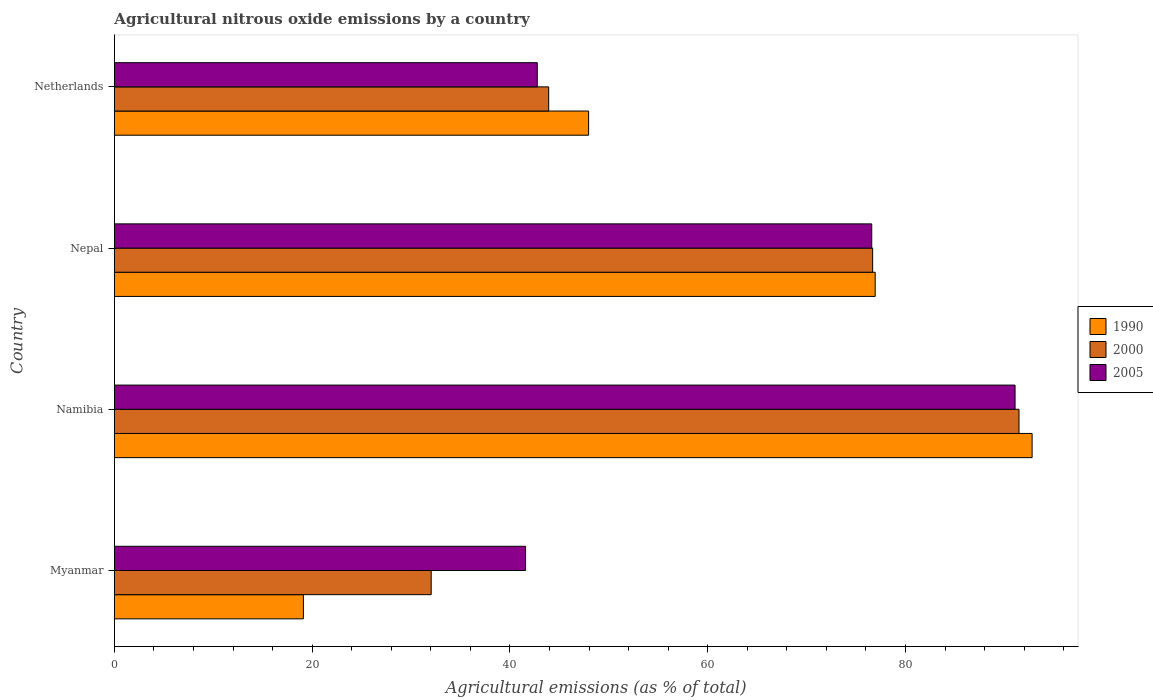How many different coloured bars are there?
Offer a terse response. 3. How many groups of bars are there?
Ensure brevity in your answer.  4. Are the number of bars per tick equal to the number of legend labels?
Give a very brief answer. Yes. What is the label of the 2nd group of bars from the top?
Give a very brief answer. Nepal. What is the amount of agricultural nitrous oxide emitted in 2000 in Myanmar?
Your answer should be compact. 32.03. Across all countries, what is the maximum amount of agricultural nitrous oxide emitted in 2000?
Provide a succinct answer. 91.48. Across all countries, what is the minimum amount of agricultural nitrous oxide emitted in 2005?
Keep it short and to the point. 41.58. In which country was the amount of agricultural nitrous oxide emitted in 2005 maximum?
Provide a short and direct response. Namibia. In which country was the amount of agricultural nitrous oxide emitted in 2000 minimum?
Offer a very short reply. Myanmar. What is the total amount of agricultural nitrous oxide emitted in 2000 in the graph?
Offer a terse response. 244.11. What is the difference between the amount of agricultural nitrous oxide emitted in 2005 in Nepal and that in Netherlands?
Make the answer very short. 33.82. What is the difference between the amount of agricultural nitrous oxide emitted in 2005 in Myanmar and the amount of agricultural nitrous oxide emitted in 2000 in Namibia?
Keep it short and to the point. -49.9. What is the average amount of agricultural nitrous oxide emitted in 2000 per country?
Your response must be concise. 61.03. What is the difference between the amount of agricultural nitrous oxide emitted in 1990 and amount of agricultural nitrous oxide emitted in 2005 in Namibia?
Give a very brief answer. 1.72. What is the ratio of the amount of agricultural nitrous oxide emitted in 1990 in Namibia to that in Nepal?
Give a very brief answer. 1.21. What is the difference between the highest and the second highest amount of agricultural nitrous oxide emitted in 2000?
Give a very brief answer. 14.8. What is the difference between the highest and the lowest amount of agricultural nitrous oxide emitted in 2005?
Your answer should be compact. 49.5. Is the sum of the amount of agricultural nitrous oxide emitted in 2000 in Namibia and Nepal greater than the maximum amount of agricultural nitrous oxide emitted in 2005 across all countries?
Your answer should be compact. Yes. What does the 1st bar from the top in Namibia represents?
Your answer should be compact. 2005. What does the 2nd bar from the bottom in Myanmar represents?
Give a very brief answer. 2000. Are all the bars in the graph horizontal?
Ensure brevity in your answer.  Yes. How many countries are there in the graph?
Provide a short and direct response. 4. Does the graph contain any zero values?
Offer a terse response. No. How many legend labels are there?
Ensure brevity in your answer.  3. How are the legend labels stacked?
Provide a short and direct response. Vertical. What is the title of the graph?
Offer a very short reply. Agricultural nitrous oxide emissions by a country. What is the label or title of the X-axis?
Offer a very short reply. Agricultural emissions (as % of total). What is the Agricultural emissions (as % of total) of 1990 in Myanmar?
Your answer should be compact. 19.11. What is the Agricultural emissions (as % of total) in 2000 in Myanmar?
Offer a very short reply. 32.03. What is the Agricultural emissions (as % of total) in 2005 in Myanmar?
Keep it short and to the point. 41.58. What is the Agricultural emissions (as % of total) of 1990 in Namibia?
Make the answer very short. 92.8. What is the Agricultural emissions (as % of total) in 2000 in Namibia?
Keep it short and to the point. 91.48. What is the Agricultural emissions (as % of total) of 2005 in Namibia?
Offer a very short reply. 91.08. What is the Agricultural emissions (as % of total) of 1990 in Nepal?
Make the answer very short. 76.93. What is the Agricultural emissions (as % of total) in 2000 in Nepal?
Provide a succinct answer. 76.68. What is the Agricultural emissions (as % of total) of 2005 in Nepal?
Provide a short and direct response. 76.59. What is the Agricultural emissions (as % of total) of 1990 in Netherlands?
Make the answer very short. 47.95. What is the Agricultural emissions (as % of total) of 2000 in Netherlands?
Your answer should be compact. 43.92. What is the Agricultural emissions (as % of total) of 2005 in Netherlands?
Give a very brief answer. 42.76. Across all countries, what is the maximum Agricultural emissions (as % of total) in 1990?
Make the answer very short. 92.8. Across all countries, what is the maximum Agricultural emissions (as % of total) of 2000?
Ensure brevity in your answer.  91.48. Across all countries, what is the maximum Agricultural emissions (as % of total) in 2005?
Give a very brief answer. 91.08. Across all countries, what is the minimum Agricultural emissions (as % of total) of 1990?
Ensure brevity in your answer.  19.11. Across all countries, what is the minimum Agricultural emissions (as % of total) of 2000?
Offer a terse response. 32.03. Across all countries, what is the minimum Agricultural emissions (as % of total) of 2005?
Your answer should be very brief. 41.58. What is the total Agricultural emissions (as % of total) in 1990 in the graph?
Provide a short and direct response. 236.8. What is the total Agricultural emissions (as % of total) of 2000 in the graph?
Offer a terse response. 244.11. What is the total Agricultural emissions (as % of total) in 2005 in the graph?
Provide a succinct answer. 252.01. What is the difference between the Agricultural emissions (as % of total) in 1990 in Myanmar and that in Namibia?
Your answer should be compact. -73.69. What is the difference between the Agricultural emissions (as % of total) of 2000 in Myanmar and that in Namibia?
Give a very brief answer. -59.45. What is the difference between the Agricultural emissions (as % of total) in 2005 in Myanmar and that in Namibia?
Make the answer very short. -49.5. What is the difference between the Agricultural emissions (as % of total) in 1990 in Myanmar and that in Nepal?
Make the answer very short. -57.82. What is the difference between the Agricultural emissions (as % of total) of 2000 in Myanmar and that in Nepal?
Keep it short and to the point. -44.65. What is the difference between the Agricultural emissions (as % of total) of 2005 in Myanmar and that in Nepal?
Ensure brevity in your answer.  -35.01. What is the difference between the Agricultural emissions (as % of total) in 1990 in Myanmar and that in Netherlands?
Give a very brief answer. -28.84. What is the difference between the Agricultural emissions (as % of total) in 2000 in Myanmar and that in Netherlands?
Your response must be concise. -11.88. What is the difference between the Agricultural emissions (as % of total) in 2005 in Myanmar and that in Netherlands?
Offer a very short reply. -1.19. What is the difference between the Agricultural emissions (as % of total) of 1990 in Namibia and that in Nepal?
Your answer should be very brief. 15.87. What is the difference between the Agricultural emissions (as % of total) of 2000 in Namibia and that in Nepal?
Your answer should be very brief. 14.8. What is the difference between the Agricultural emissions (as % of total) in 2005 in Namibia and that in Nepal?
Your answer should be very brief. 14.49. What is the difference between the Agricultural emissions (as % of total) in 1990 in Namibia and that in Netherlands?
Provide a succinct answer. 44.85. What is the difference between the Agricultural emissions (as % of total) of 2000 in Namibia and that in Netherlands?
Your answer should be compact. 47.56. What is the difference between the Agricultural emissions (as % of total) of 2005 in Namibia and that in Netherlands?
Give a very brief answer. 48.32. What is the difference between the Agricultural emissions (as % of total) of 1990 in Nepal and that in Netherlands?
Give a very brief answer. 28.98. What is the difference between the Agricultural emissions (as % of total) of 2000 in Nepal and that in Netherlands?
Ensure brevity in your answer.  32.76. What is the difference between the Agricultural emissions (as % of total) in 2005 in Nepal and that in Netherlands?
Your answer should be very brief. 33.82. What is the difference between the Agricultural emissions (as % of total) of 1990 in Myanmar and the Agricultural emissions (as % of total) of 2000 in Namibia?
Your answer should be compact. -72.37. What is the difference between the Agricultural emissions (as % of total) of 1990 in Myanmar and the Agricultural emissions (as % of total) of 2005 in Namibia?
Offer a terse response. -71.97. What is the difference between the Agricultural emissions (as % of total) of 2000 in Myanmar and the Agricultural emissions (as % of total) of 2005 in Namibia?
Your answer should be compact. -59.05. What is the difference between the Agricultural emissions (as % of total) in 1990 in Myanmar and the Agricultural emissions (as % of total) in 2000 in Nepal?
Ensure brevity in your answer.  -57.57. What is the difference between the Agricultural emissions (as % of total) of 1990 in Myanmar and the Agricultural emissions (as % of total) of 2005 in Nepal?
Give a very brief answer. -57.48. What is the difference between the Agricultural emissions (as % of total) of 2000 in Myanmar and the Agricultural emissions (as % of total) of 2005 in Nepal?
Ensure brevity in your answer.  -44.55. What is the difference between the Agricultural emissions (as % of total) of 1990 in Myanmar and the Agricultural emissions (as % of total) of 2000 in Netherlands?
Your response must be concise. -24.81. What is the difference between the Agricultural emissions (as % of total) of 1990 in Myanmar and the Agricultural emissions (as % of total) of 2005 in Netherlands?
Your answer should be compact. -23.65. What is the difference between the Agricultural emissions (as % of total) in 2000 in Myanmar and the Agricultural emissions (as % of total) in 2005 in Netherlands?
Your response must be concise. -10.73. What is the difference between the Agricultural emissions (as % of total) in 1990 in Namibia and the Agricultural emissions (as % of total) in 2000 in Nepal?
Offer a very short reply. 16.13. What is the difference between the Agricultural emissions (as % of total) in 1990 in Namibia and the Agricultural emissions (as % of total) in 2005 in Nepal?
Provide a succinct answer. 16.22. What is the difference between the Agricultural emissions (as % of total) of 2000 in Namibia and the Agricultural emissions (as % of total) of 2005 in Nepal?
Your answer should be very brief. 14.89. What is the difference between the Agricultural emissions (as % of total) of 1990 in Namibia and the Agricultural emissions (as % of total) of 2000 in Netherlands?
Offer a very short reply. 48.89. What is the difference between the Agricultural emissions (as % of total) in 1990 in Namibia and the Agricultural emissions (as % of total) in 2005 in Netherlands?
Give a very brief answer. 50.04. What is the difference between the Agricultural emissions (as % of total) in 2000 in Namibia and the Agricultural emissions (as % of total) in 2005 in Netherlands?
Provide a short and direct response. 48.72. What is the difference between the Agricultural emissions (as % of total) in 1990 in Nepal and the Agricultural emissions (as % of total) in 2000 in Netherlands?
Provide a short and direct response. 33.02. What is the difference between the Agricultural emissions (as % of total) of 1990 in Nepal and the Agricultural emissions (as % of total) of 2005 in Netherlands?
Make the answer very short. 34.17. What is the difference between the Agricultural emissions (as % of total) of 2000 in Nepal and the Agricultural emissions (as % of total) of 2005 in Netherlands?
Provide a short and direct response. 33.92. What is the average Agricultural emissions (as % of total) of 1990 per country?
Provide a succinct answer. 59.2. What is the average Agricultural emissions (as % of total) in 2000 per country?
Your response must be concise. 61.03. What is the average Agricultural emissions (as % of total) of 2005 per country?
Your answer should be compact. 63. What is the difference between the Agricultural emissions (as % of total) of 1990 and Agricultural emissions (as % of total) of 2000 in Myanmar?
Provide a short and direct response. -12.92. What is the difference between the Agricultural emissions (as % of total) in 1990 and Agricultural emissions (as % of total) in 2005 in Myanmar?
Offer a terse response. -22.47. What is the difference between the Agricultural emissions (as % of total) of 2000 and Agricultural emissions (as % of total) of 2005 in Myanmar?
Keep it short and to the point. -9.54. What is the difference between the Agricultural emissions (as % of total) in 1990 and Agricultural emissions (as % of total) in 2000 in Namibia?
Your answer should be compact. 1.32. What is the difference between the Agricultural emissions (as % of total) in 1990 and Agricultural emissions (as % of total) in 2005 in Namibia?
Your answer should be very brief. 1.72. What is the difference between the Agricultural emissions (as % of total) of 2000 and Agricultural emissions (as % of total) of 2005 in Namibia?
Provide a short and direct response. 0.4. What is the difference between the Agricultural emissions (as % of total) of 1990 and Agricultural emissions (as % of total) of 2000 in Nepal?
Your answer should be compact. 0.26. What is the difference between the Agricultural emissions (as % of total) of 1990 and Agricultural emissions (as % of total) of 2005 in Nepal?
Your answer should be very brief. 0.35. What is the difference between the Agricultural emissions (as % of total) in 2000 and Agricultural emissions (as % of total) in 2005 in Nepal?
Offer a very short reply. 0.09. What is the difference between the Agricultural emissions (as % of total) in 1990 and Agricultural emissions (as % of total) in 2000 in Netherlands?
Your answer should be compact. 4.04. What is the difference between the Agricultural emissions (as % of total) of 1990 and Agricultural emissions (as % of total) of 2005 in Netherlands?
Ensure brevity in your answer.  5.19. What is the difference between the Agricultural emissions (as % of total) of 2000 and Agricultural emissions (as % of total) of 2005 in Netherlands?
Your answer should be compact. 1.15. What is the ratio of the Agricultural emissions (as % of total) in 1990 in Myanmar to that in Namibia?
Offer a very short reply. 0.21. What is the ratio of the Agricultural emissions (as % of total) of 2000 in Myanmar to that in Namibia?
Provide a succinct answer. 0.35. What is the ratio of the Agricultural emissions (as % of total) in 2005 in Myanmar to that in Namibia?
Give a very brief answer. 0.46. What is the ratio of the Agricultural emissions (as % of total) of 1990 in Myanmar to that in Nepal?
Offer a terse response. 0.25. What is the ratio of the Agricultural emissions (as % of total) in 2000 in Myanmar to that in Nepal?
Your answer should be compact. 0.42. What is the ratio of the Agricultural emissions (as % of total) of 2005 in Myanmar to that in Nepal?
Your response must be concise. 0.54. What is the ratio of the Agricultural emissions (as % of total) in 1990 in Myanmar to that in Netherlands?
Your answer should be very brief. 0.4. What is the ratio of the Agricultural emissions (as % of total) in 2000 in Myanmar to that in Netherlands?
Your response must be concise. 0.73. What is the ratio of the Agricultural emissions (as % of total) of 2005 in Myanmar to that in Netherlands?
Ensure brevity in your answer.  0.97. What is the ratio of the Agricultural emissions (as % of total) of 1990 in Namibia to that in Nepal?
Make the answer very short. 1.21. What is the ratio of the Agricultural emissions (as % of total) of 2000 in Namibia to that in Nepal?
Your response must be concise. 1.19. What is the ratio of the Agricultural emissions (as % of total) of 2005 in Namibia to that in Nepal?
Offer a terse response. 1.19. What is the ratio of the Agricultural emissions (as % of total) of 1990 in Namibia to that in Netherlands?
Keep it short and to the point. 1.94. What is the ratio of the Agricultural emissions (as % of total) of 2000 in Namibia to that in Netherlands?
Your answer should be compact. 2.08. What is the ratio of the Agricultural emissions (as % of total) in 2005 in Namibia to that in Netherlands?
Give a very brief answer. 2.13. What is the ratio of the Agricultural emissions (as % of total) in 1990 in Nepal to that in Netherlands?
Your answer should be very brief. 1.6. What is the ratio of the Agricultural emissions (as % of total) of 2000 in Nepal to that in Netherlands?
Make the answer very short. 1.75. What is the ratio of the Agricultural emissions (as % of total) of 2005 in Nepal to that in Netherlands?
Your response must be concise. 1.79. What is the difference between the highest and the second highest Agricultural emissions (as % of total) in 1990?
Your response must be concise. 15.87. What is the difference between the highest and the second highest Agricultural emissions (as % of total) of 2000?
Give a very brief answer. 14.8. What is the difference between the highest and the second highest Agricultural emissions (as % of total) of 2005?
Offer a very short reply. 14.49. What is the difference between the highest and the lowest Agricultural emissions (as % of total) of 1990?
Provide a succinct answer. 73.69. What is the difference between the highest and the lowest Agricultural emissions (as % of total) of 2000?
Make the answer very short. 59.45. What is the difference between the highest and the lowest Agricultural emissions (as % of total) in 2005?
Provide a short and direct response. 49.5. 